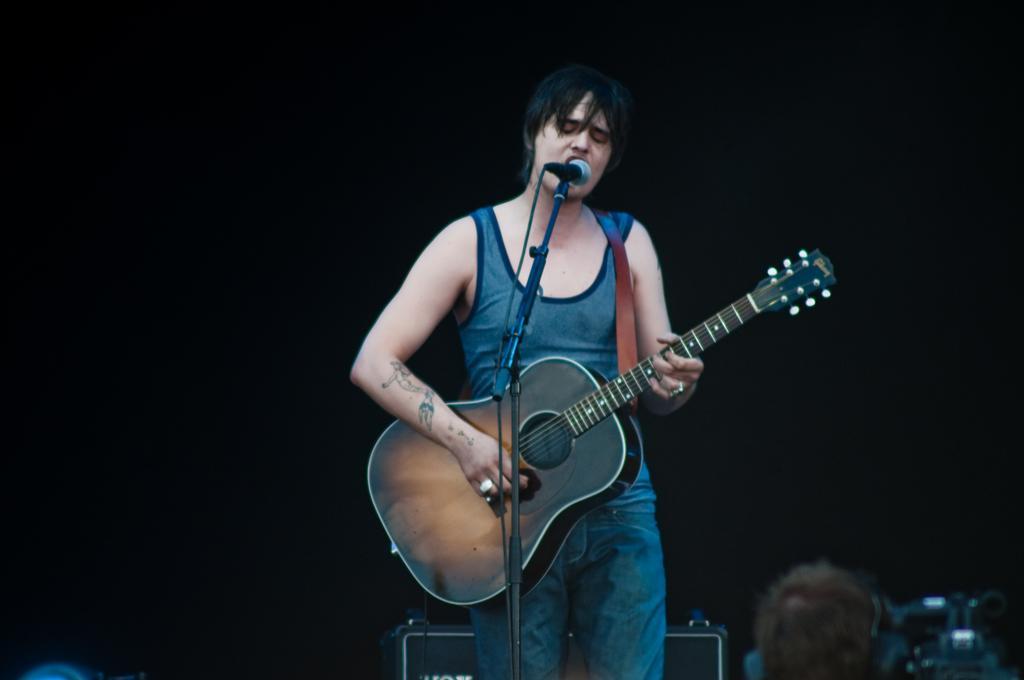How would you summarize this image in a sentence or two? In this image, we can see a person is playing a guitar. He wear a tattoo on his right hand. On left hand, he wear a ring. In the bottom of the image, we can found a human head and camera here. 